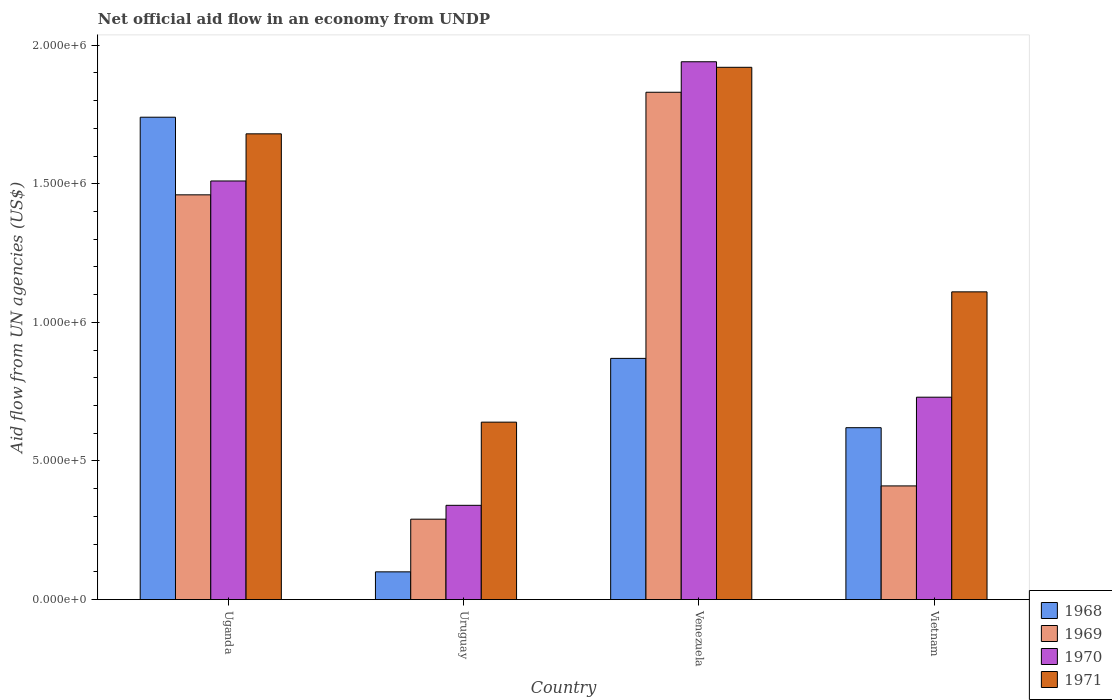Are the number of bars per tick equal to the number of legend labels?
Provide a short and direct response. Yes. How many bars are there on the 3rd tick from the right?
Offer a very short reply. 4. What is the label of the 2nd group of bars from the left?
Give a very brief answer. Uruguay. In how many cases, is the number of bars for a given country not equal to the number of legend labels?
Your answer should be very brief. 0. What is the net official aid flow in 1971 in Uruguay?
Your answer should be very brief. 6.40e+05. Across all countries, what is the maximum net official aid flow in 1968?
Your answer should be very brief. 1.74e+06. In which country was the net official aid flow in 1968 maximum?
Provide a succinct answer. Uganda. In which country was the net official aid flow in 1969 minimum?
Keep it short and to the point. Uruguay. What is the total net official aid flow in 1969 in the graph?
Make the answer very short. 3.99e+06. What is the difference between the net official aid flow in 1968 in Uganda and that in Uruguay?
Offer a terse response. 1.64e+06. What is the difference between the net official aid flow in 1969 in Uruguay and the net official aid flow in 1970 in Venezuela?
Your response must be concise. -1.65e+06. What is the average net official aid flow in 1968 per country?
Offer a terse response. 8.32e+05. What is the difference between the net official aid flow of/in 1971 and net official aid flow of/in 1970 in Uganda?
Give a very brief answer. 1.70e+05. What is the ratio of the net official aid flow in 1970 in Uganda to that in Venezuela?
Provide a succinct answer. 0.78. What is the difference between the highest and the lowest net official aid flow in 1969?
Your answer should be very brief. 1.54e+06. What does the 1st bar from the left in Venezuela represents?
Ensure brevity in your answer.  1968. What does the 1st bar from the right in Uruguay represents?
Provide a succinct answer. 1971. Are all the bars in the graph horizontal?
Make the answer very short. No. What is the difference between two consecutive major ticks on the Y-axis?
Keep it short and to the point. 5.00e+05. Does the graph contain any zero values?
Give a very brief answer. No. Where does the legend appear in the graph?
Your response must be concise. Bottom right. How are the legend labels stacked?
Give a very brief answer. Vertical. What is the title of the graph?
Ensure brevity in your answer.  Net official aid flow in an economy from UNDP. Does "1995" appear as one of the legend labels in the graph?
Your response must be concise. No. What is the label or title of the Y-axis?
Your response must be concise. Aid flow from UN agencies (US$). What is the Aid flow from UN agencies (US$) in 1968 in Uganda?
Your answer should be very brief. 1.74e+06. What is the Aid flow from UN agencies (US$) of 1969 in Uganda?
Provide a short and direct response. 1.46e+06. What is the Aid flow from UN agencies (US$) in 1970 in Uganda?
Ensure brevity in your answer.  1.51e+06. What is the Aid flow from UN agencies (US$) of 1971 in Uganda?
Offer a very short reply. 1.68e+06. What is the Aid flow from UN agencies (US$) of 1969 in Uruguay?
Ensure brevity in your answer.  2.90e+05. What is the Aid flow from UN agencies (US$) of 1971 in Uruguay?
Ensure brevity in your answer.  6.40e+05. What is the Aid flow from UN agencies (US$) in 1968 in Venezuela?
Offer a very short reply. 8.70e+05. What is the Aid flow from UN agencies (US$) in 1969 in Venezuela?
Your response must be concise. 1.83e+06. What is the Aid flow from UN agencies (US$) of 1970 in Venezuela?
Offer a terse response. 1.94e+06. What is the Aid flow from UN agencies (US$) in 1971 in Venezuela?
Offer a very short reply. 1.92e+06. What is the Aid flow from UN agencies (US$) in 1968 in Vietnam?
Keep it short and to the point. 6.20e+05. What is the Aid flow from UN agencies (US$) of 1969 in Vietnam?
Your answer should be compact. 4.10e+05. What is the Aid flow from UN agencies (US$) of 1970 in Vietnam?
Make the answer very short. 7.30e+05. What is the Aid flow from UN agencies (US$) of 1971 in Vietnam?
Make the answer very short. 1.11e+06. Across all countries, what is the maximum Aid flow from UN agencies (US$) in 1968?
Provide a succinct answer. 1.74e+06. Across all countries, what is the maximum Aid flow from UN agencies (US$) in 1969?
Ensure brevity in your answer.  1.83e+06. Across all countries, what is the maximum Aid flow from UN agencies (US$) of 1970?
Provide a short and direct response. 1.94e+06. Across all countries, what is the maximum Aid flow from UN agencies (US$) of 1971?
Offer a terse response. 1.92e+06. Across all countries, what is the minimum Aid flow from UN agencies (US$) of 1969?
Offer a very short reply. 2.90e+05. Across all countries, what is the minimum Aid flow from UN agencies (US$) in 1971?
Give a very brief answer. 6.40e+05. What is the total Aid flow from UN agencies (US$) in 1968 in the graph?
Offer a terse response. 3.33e+06. What is the total Aid flow from UN agencies (US$) of 1969 in the graph?
Offer a terse response. 3.99e+06. What is the total Aid flow from UN agencies (US$) of 1970 in the graph?
Offer a very short reply. 4.52e+06. What is the total Aid flow from UN agencies (US$) in 1971 in the graph?
Give a very brief answer. 5.35e+06. What is the difference between the Aid flow from UN agencies (US$) of 1968 in Uganda and that in Uruguay?
Your answer should be very brief. 1.64e+06. What is the difference between the Aid flow from UN agencies (US$) of 1969 in Uganda and that in Uruguay?
Give a very brief answer. 1.17e+06. What is the difference between the Aid flow from UN agencies (US$) of 1970 in Uganda and that in Uruguay?
Keep it short and to the point. 1.17e+06. What is the difference between the Aid flow from UN agencies (US$) of 1971 in Uganda and that in Uruguay?
Your response must be concise. 1.04e+06. What is the difference between the Aid flow from UN agencies (US$) in 1968 in Uganda and that in Venezuela?
Your answer should be compact. 8.70e+05. What is the difference between the Aid flow from UN agencies (US$) of 1969 in Uganda and that in Venezuela?
Provide a short and direct response. -3.70e+05. What is the difference between the Aid flow from UN agencies (US$) of 1970 in Uganda and that in Venezuela?
Keep it short and to the point. -4.30e+05. What is the difference between the Aid flow from UN agencies (US$) of 1968 in Uganda and that in Vietnam?
Provide a succinct answer. 1.12e+06. What is the difference between the Aid flow from UN agencies (US$) of 1969 in Uganda and that in Vietnam?
Your answer should be very brief. 1.05e+06. What is the difference between the Aid flow from UN agencies (US$) of 1970 in Uganda and that in Vietnam?
Give a very brief answer. 7.80e+05. What is the difference between the Aid flow from UN agencies (US$) in 1971 in Uganda and that in Vietnam?
Offer a very short reply. 5.70e+05. What is the difference between the Aid flow from UN agencies (US$) in 1968 in Uruguay and that in Venezuela?
Ensure brevity in your answer.  -7.70e+05. What is the difference between the Aid flow from UN agencies (US$) in 1969 in Uruguay and that in Venezuela?
Provide a succinct answer. -1.54e+06. What is the difference between the Aid flow from UN agencies (US$) in 1970 in Uruguay and that in Venezuela?
Make the answer very short. -1.60e+06. What is the difference between the Aid flow from UN agencies (US$) of 1971 in Uruguay and that in Venezuela?
Provide a short and direct response. -1.28e+06. What is the difference between the Aid flow from UN agencies (US$) in 1968 in Uruguay and that in Vietnam?
Ensure brevity in your answer.  -5.20e+05. What is the difference between the Aid flow from UN agencies (US$) in 1969 in Uruguay and that in Vietnam?
Your answer should be compact. -1.20e+05. What is the difference between the Aid flow from UN agencies (US$) of 1970 in Uruguay and that in Vietnam?
Your answer should be very brief. -3.90e+05. What is the difference between the Aid flow from UN agencies (US$) in 1971 in Uruguay and that in Vietnam?
Provide a short and direct response. -4.70e+05. What is the difference between the Aid flow from UN agencies (US$) of 1968 in Venezuela and that in Vietnam?
Your answer should be compact. 2.50e+05. What is the difference between the Aid flow from UN agencies (US$) in 1969 in Venezuela and that in Vietnam?
Provide a short and direct response. 1.42e+06. What is the difference between the Aid flow from UN agencies (US$) of 1970 in Venezuela and that in Vietnam?
Keep it short and to the point. 1.21e+06. What is the difference between the Aid flow from UN agencies (US$) in 1971 in Venezuela and that in Vietnam?
Make the answer very short. 8.10e+05. What is the difference between the Aid flow from UN agencies (US$) of 1968 in Uganda and the Aid flow from UN agencies (US$) of 1969 in Uruguay?
Your answer should be very brief. 1.45e+06. What is the difference between the Aid flow from UN agencies (US$) in 1968 in Uganda and the Aid flow from UN agencies (US$) in 1970 in Uruguay?
Your answer should be compact. 1.40e+06. What is the difference between the Aid flow from UN agencies (US$) of 1968 in Uganda and the Aid flow from UN agencies (US$) of 1971 in Uruguay?
Ensure brevity in your answer.  1.10e+06. What is the difference between the Aid flow from UN agencies (US$) in 1969 in Uganda and the Aid flow from UN agencies (US$) in 1970 in Uruguay?
Your answer should be very brief. 1.12e+06. What is the difference between the Aid flow from UN agencies (US$) in 1969 in Uganda and the Aid flow from UN agencies (US$) in 1971 in Uruguay?
Your answer should be very brief. 8.20e+05. What is the difference between the Aid flow from UN agencies (US$) of 1970 in Uganda and the Aid flow from UN agencies (US$) of 1971 in Uruguay?
Your response must be concise. 8.70e+05. What is the difference between the Aid flow from UN agencies (US$) of 1969 in Uganda and the Aid flow from UN agencies (US$) of 1970 in Venezuela?
Ensure brevity in your answer.  -4.80e+05. What is the difference between the Aid flow from UN agencies (US$) in 1969 in Uganda and the Aid flow from UN agencies (US$) in 1971 in Venezuela?
Ensure brevity in your answer.  -4.60e+05. What is the difference between the Aid flow from UN agencies (US$) of 1970 in Uganda and the Aid flow from UN agencies (US$) of 1971 in Venezuela?
Offer a very short reply. -4.10e+05. What is the difference between the Aid flow from UN agencies (US$) of 1968 in Uganda and the Aid flow from UN agencies (US$) of 1969 in Vietnam?
Offer a very short reply. 1.33e+06. What is the difference between the Aid flow from UN agencies (US$) of 1968 in Uganda and the Aid flow from UN agencies (US$) of 1970 in Vietnam?
Provide a short and direct response. 1.01e+06. What is the difference between the Aid flow from UN agencies (US$) in 1968 in Uganda and the Aid flow from UN agencies (US$) in 1971 in Vietnam?
Your response must be concise. 6.30e+05. What is the difference between the Aid flow from UN agencies (US$) in 1969 in Uganda and the Aid flow from UN agencies (US$) in 1970 in Vietnam?
Offer a very short reply. 7.30e+05. What is the difference between the Aid flow from UN agencies (US$) in 1968 in Uruguay and the Aid flow from UN agencies (US$) in 1969 in Venezuela?
Provide a succinct answer. -1.73e+06. What is the difference between the Aid flow from UN agencies (US$) of 1968 in Uruguay and the Aid flow from UN agencies (US$) of 1970 in Venezuela?
Give a very brief answer. -1.84e+06. What is the difference between the Aid flow from UN agencies (US$) of 1968 in Uruguay and the Aid flow from UN agencies (US$) of 1971 in Venezuela?
Ensure brevity in your answer.  -1.82e+06. What is the difference between the Aid flow from UN agencies (US$) in 1969 in Uruguay and the Aid flow from UN agencies (US$) in 1970 in Venezuela?
Give a very brief answer. -1.65e+06. What is the difference between the Aid flow from UN agencies (US$) in 1969 in Uruguay and the Aid flow from UN agencies (US$) in 1971 in Venezuela?
Ensure brevity in your answer.  -1.63e+06. What is the difference between the Aid flow from UN agencies (US$) of 1970 in Uruguay and the Aid flow from UN agencies (US$) of 1971 in Venezuela?
Provide a succinct answer. -1.58e+06. What is the difference between the Aid flow from UN agencies (US$) of 1968 in Uruguay and the Aid flow from UN agencies (US$) of 1969 in Vietnam?
Give a very brief answer. -3.10e+05. What is the difference between the Aid flow from UN agencies (US$) in 1968 in Uruguay and the Aid flow from UN agencies (US$) in 1970 in Vietnam?
Offer a very short reply. -6.30e+05. What is the difference between the Aid flow from UN agencies (US$) of 1968 in Uruguay and the Aid flow from UN agencies (US$) of 1971 in Vietnam?
Your answer should be compact. -1.01e+06. What is the difference between the Aid flow from UN agencies (US$) of 1969 in Uruguay and the Aid flow from UN agencies (US$) of 1970 in Vietnam?
Give a very brief answer. -4.40e+05. What is the difference between the Aid flow from UN agencies (US$) of 1969 in Uruguay and the Aid flow from UN agencies (US$) of 1971 in Vietnam?
Offer a very short reply. -8.20e+05. What is the difference between the Aid flow from UN agencies (US$) in 1970 in Uruguay and the Aid flow from UN agencies (US$) in 1971 in Vietnam?
Provide a short and direct response. -7.70e+05. What is the difference between the Aid flow from UN agencies (US$) in 1968 in Venezuela and the Aid flow from UN agencies (US$) in 1969 in Vietnam?
Give a very brief answer. 4.60e+05. What is the difference between the Aid flow from UN agencies (US$) in 1968 in Venezuela and the Aid flow from UN agencies (US$) in 1970 in Vietnam?
Keep it short and to the point. 1.40e+05. What is the difference between the Aid flow from UN agencies (US$) of 1969 in Venezuela and the Aid flow from UN agencies (US$) of 1970 in Vietnam?
Give a very brief answer. 1.10e+06. What is the difference between the Aid flow from UN agencies (US$) in 1969 in Venezuela and the Aid flow from UN agencies (US$) in 1971 in Vietnam?
Your answer should be very brief. 7.20e+05. What is the difference between the Aid flow from UN agencies (US$) of 1970 in Venezuela and the Aid flow from UN agencies (US$) of 1971 in Vietnam?
Your answer should be very brief. 8.30e+05. What is the average Aid flow from UN agencies (US$) in 1968 per country?
Offer a terse response. 8.32e+05. What is the average Aid flow from UN agencies (US$) in 1969 per country?
Ensure brevity in your answer.  9.98e+05. What is the average Aid flow from UN agencies (US$) of 1970 per country?
Your response must be concise. 1.13e+06. What is the average Aid flow from UN agencies (US$) of 1971 per country?
Offer a very short reply. 1.34e+06. What is the difference between the Aid flow from UN agencies (US$) of 1968 and Aid flow from UN agencies (US$) of 1969 in Uganda?
Offer a very short reply. 2.80e+05. What is the difference between the Aid flow from UN agencies (US$) of 1968 and Aid flow from UN agencies (US$) of 1970 in Uganda?
Offer a very short reply. 2.30e+05. What is the difference between the Aid flow from UN agencies (US$) in 1969 and Aid flow from UN agencies (US$) in 1971 in Uganda?
Your response must be concise. -2.20e+05. What is the difference between the Aid flow from UN agencies (US$) in 1970 and Aid flow from UN agencies (US$) in 1971 in Uganda?
Keep it short and to the point. -1.70e+05. What is the difference between the Aid flow from UN agencies (US$) in 1968 and Aid flow from UN agencies (US$) in 1969 in Uruguay?
Offer a terse response. -1.90e+05. What is the difference between the Aid flow from UN agencies (US$) of 1968 and Aid flow from UN agencies (US$) of 1970 in Uruguay?
Provide a short and direct response. -2.40e+05. What is the difference between the Aid flow from UN agencies (US$) in 1968 and Aid flow from UN agencies (US$) in 1971 in Uruguay?
Keep it short and to the point. -5.40e+05. What is the difference between the Aid flow from UN agencies (US$) of 1969 and Aid flow from UN agencies (US$) of 1971 in Uruguay?
Your answer should be compact. -3.50e+05. What is the difference between the Aid flow from UN agencies (US$) of 1970 and Aid flow from UN agencies (US$) of 1971 in Uruguay?
Your answer should be very brief. -3.00e+05. What is the difference between the Aid flow from UN agencies (US$) of 1968 and Aid flow from UN agencies (US$) of 1969 in Venezuela?
Provide a short and direct response. -9.60e+05. What is the difference between the Aid flow from UN agencies (US$) in 1968 and Aid flow from UN agencies (US$) in 1970 in Venezuela?
Your answer should be very brief. -1.07e+06. What is the difference between the Aid flow from UN agencies (US$) in 1968 and Aid flow from UN agencies (US$) in 1971 in Venezuela?
Give a very brief answer. -1.05e+06. What is the difference between the Aid flow from UN agencies (US$) in 1969 and Aid flow from UN agencies (US$) in 1970 in Venezuela?
Your answer should be compact. -1.10e+05. What is the difference between the Aid flow from UN agencies (US$) in 1970 and Aid flow from UN agencies (US$) in 1971 in Venezuela?
Your answer should be very brief. 2.00e+04. What is the difference between the Aid flow from UN agencies (US$) of 1968 and Aid flow from UN agencies (US$) of 1969 in Vietnam?
Give a very brief answer. 2.10e+05. What is the difference between the Aid flow from UN agencies (US$) of 1968 and Aid flow from UN agencies (US$) of 1971 in Vietnam?
Your answer should be very brief. -4.90e+05. What is the difference between the Aid flow from UN agencies (US$) in 1969 and Aid flow from UN agencies (US$) in 1970 in Vietnam?
Your answer should be compact. -3.20e+05. What is the difference between the Aid flow from UN agencies (US$) of 1969 and Aid flow from UN agencies (US$) of 1971 in Vietnam?
Offer a very short reply. -7.00e+05. What is the difference between the Aid flow from UN agencies (US$) in 1970 and Aid flow from UN agencies (US$) in 1971 in Vietnam?
Your answer should be compact. -3.80e+05. What is the ratio of the Aid flow from UN agencies (US$) of 1968 in Uganda to that in Uruguay?
Your answer should be compact. 17.4. What is the ratio of the Aid flow from UN agencies (US$) in 1969 in Uganda to that in Uruguay?
Ensure brevity in your answer.  5.03. What is the ratio of the Aid flow from UN agencies (US$) in 1970 in Uganda to that in Uruguay?
Make the answer very short. 4.44. What is the ratio of the Aid flow from UN agencies (US$) of 1971 in Uganda to that in Uruguay?
Offer a terse response. 2.62. What is the ratio of the Aid flow from UN agencies (US$) of 1968 in Uganda to that in Venezuela?
Provide a succinct answer. 2. What is the ratio of the Aid flow from UN agencies (US$) in 1969 in Uganda to that in Venezuela?
Make the answer very short. 0.8. What is the ratio of the Aid flow from UN agencies (US$) of 1970 in Uganda to that in Venezuela?
Provide a succinct answer. 0.78. What is the ratio of the Aid flow from UN agencies (US$) in 1968 in Uganda to that in Vietnam?
Provide a succinct answer. 2.81. What is the ratio of the Aid flow from UN agencies (US$) in 1969 in Uganda to that in Vietnam?
Ensure brevity in your answer.  3.56. What is the ratio of the Aid flow from UN agencies (US$) of 1970 in Uganda to that in Vietnam?
Offer a very short reply. 2.07. What is the ratio of the Aid flow from UN agencies (US$) of 1971 in Uganda to that in Vietnam?
Provide a short and direct response. 1.51. What is the ratio of the Aid flow from UN agencies (US$) of 1968 in Uruguay to that in Venezuela?
Make the answer very short. 0.11. What is the ratio of the Aid flow from UN agencies (US$) of 1969 in Uruguay to that in Venezuela?
Make the answer very short. 0.16. What is the ratio of the Aid flow from UN agencies (US$) of 1970 in Uruguay to that in Venezuela?
Ensure brevity in your answer.  0.18. What is the ratio of the Aid flow from UN agencies (US$) in 1968 in Uruguay to that in Vietnam?
Your response must be concise. 0.16. What is the ratio of the Aid flow from UN agencies (US$) in 1969 in Uruguay to that in Vietnam?
Ensure brevity in your answer.  0.71. What is the ratio of the Aid flow from UN agencies (US$) in 1970 in Uruguay to that in Vietnam?
Make the answer very short. 0.47. What is the ratio of the Aid flow from UN agencies (US$) in 1971 in Uruguay to that in Vietnam?
Your answer should be compact. 0.58. What is the ratio of the Aid flow from UN agencies (US$) in 1968 in Venezuela to that in Vietnam?
Provide a succinct answer. 1.4. What is the ratio of the Aid flow from UN agencies (US$) of 1969 in Venezuela to that in Vietnam?
Give a very brief answer. 4.46. What is the ratio of the Aid flow from UN agencies (US$) of 1970 in Venezuela to that in Vietnam?
Make the answer very short. 2.66. What is the ratio of the Aid flow from UN agencies (US$) in 1971 in Venezuela to that in Vietnam?
Keep it short and to the point. 1.73. What is the difference between the highest and the second highest Aid flow from UN agencies (US$) in 1968?
Provide a succinct answer. 8.70e+05. What is the difference between the highest and the second highest Aid flow from UN agencies (US$) of 1971?
Ensure brevity in your answer.  2.40e+05. What is the difference between the highest and the lowest Aid flow from UN agencies (US$) of 1968?
Offer a very short reply. 1.64e+06. What is the difference between the highest and the lowest Aid flow from UN agencies (US$) in 1969?
Make the answer very short. 1.54e+06. What is the difference between the highest and the lowest Aid flow from UN agencies (US$) of 1970?
Provide a short and direct response. 1.60e+06. What is the difference between the highest and the lowest Aid flow from UN agencies (US$) in 1971?
Keep it short and to the point. 1.28e+06. 